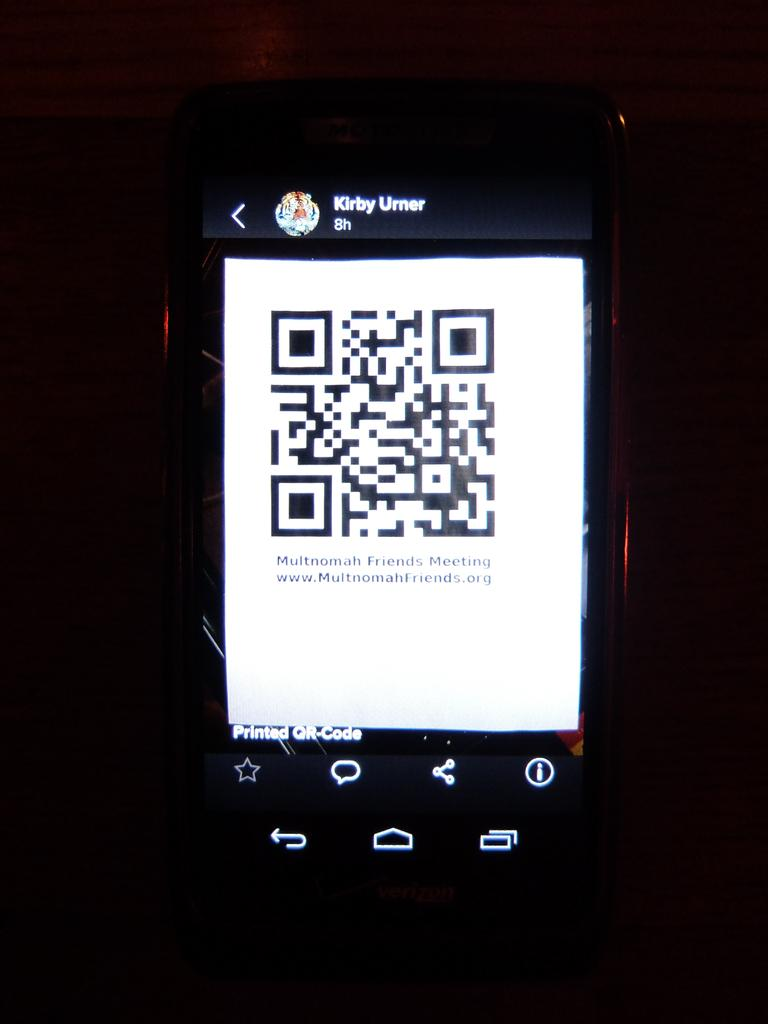<image>
Summarize the visual content of the image. a phone with the name Kirby at the top of it 